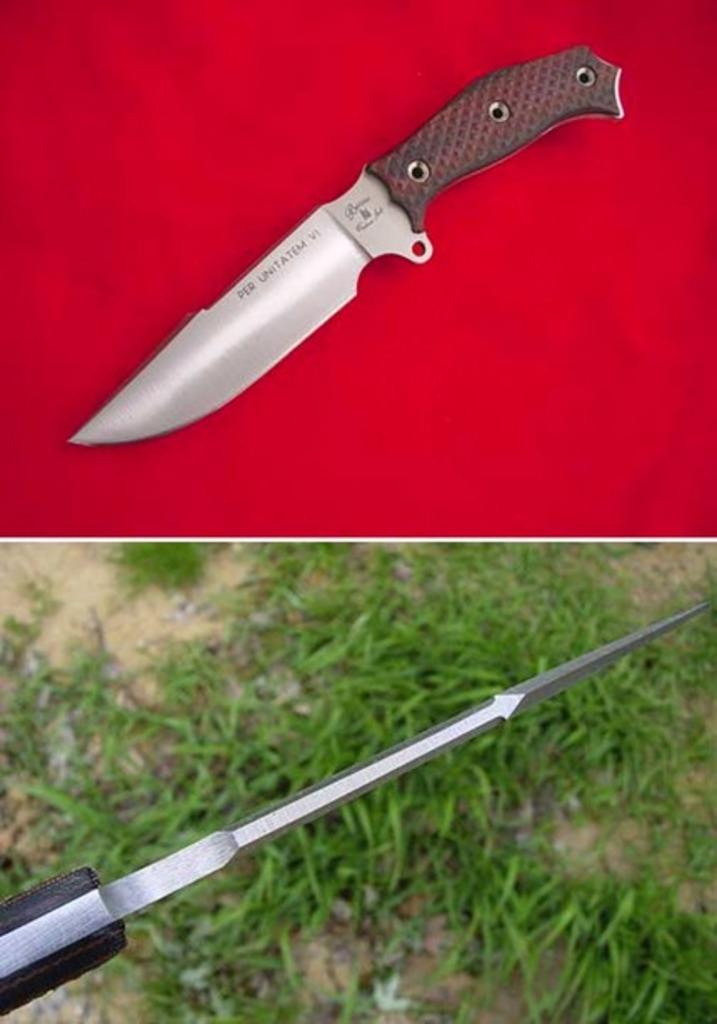How many images are combined in the collage? The collage is a combination of two images. What objects can be seen in the first image? The first image contains a knife. What object can be seen in the second image? The second image contains a drill bit. How does the deer in the image learn to use the adjustment tool? There is no deer present in the image, and therefore no learning or adjustment tool can be observed. 